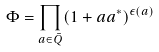Convert formula to latex. <formula><loc_0><loc_0><loc_500><loc_500>\Phi = \prod _ { a \in \bar { Q } } ( 1 + a a ^ { \ast } ) ^ { \epsilon ( a ) }</formula> 